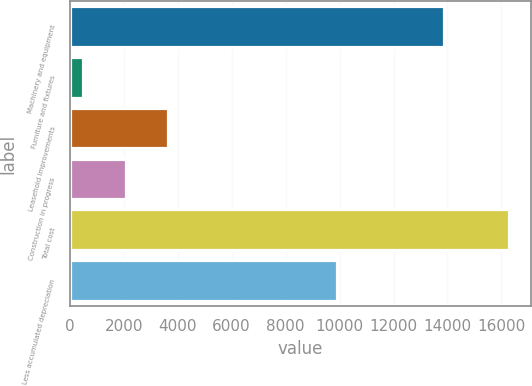Convert chart. <chart><loc_0><loc_0><loc_500><loc_500><bar_chart><fcel>Machinery and equipment<fcel>Furniture and fixtures<fcel>Leasehold improvements<fcel>Construction in progress<fcel>Total cost<fcel>Less accumulated depreciation<nl><fcel>13860<fcel>498<fcel>3653<fcel>2075.5<fcel>16273<fcel>9895<nl></chart> 